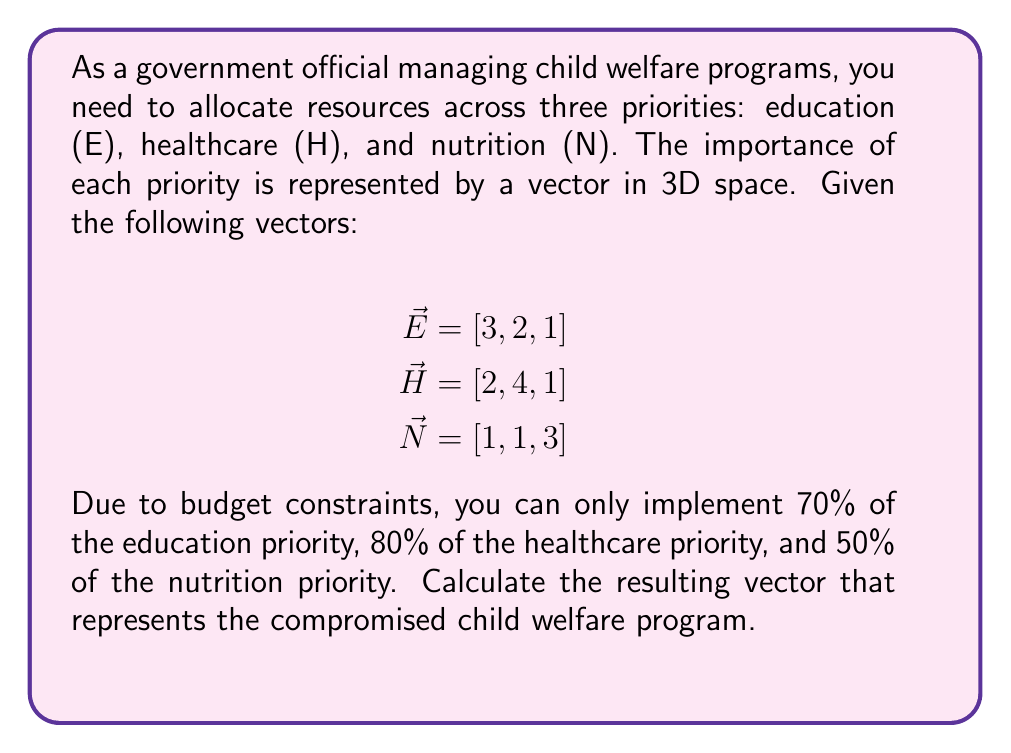Provide a solution to this math problem. To solve this problem, we need to use scalar multiplication and vector addition. Let's break it down step-by-step:

1) First, we need to apply the budget constraints to each priority vector using scalar multiplication:

   Education: $0.70 \cdot \vec{E} = 0.70 \cdot [3, 2, 1] = [2.1, 1.4, 0.7]$
   Healthcare: $0.80 \cdot \vec{H} = 0.80 \cdot [2, 4, 1] = [1.6, 3.2, 0.8]$
   Nutrition: $0.50 \cdot \vec{N} = 0.50 \cdot [1, 1, 3] = [0.5, 0.5, 1.5]$

2) Now, we need to add these scaled vectors to get the resulting compromised program vector:

   $\vec{R} = 0.70\vec{E} + 0.80\vec{H} + 0.50\vec{N}$

3) Let's add the vectors component-wise:

   $\vec{R} = [2.1, 1.4, 0.7] + [1.6, 3.2, 0.8] + [0.5, 0.5, 1.5]$

4) Summing up each component:

   $\vec{R} = [2.1 + 1.6 + 0.5, 1.4 + 3.2 + 0.5, 0.7 + 0.8 + 1.5]$

5) Calculating the final result:

   $\vec{R} = [4.2, 5.1, 3.0]$

This resulting vector represents the compromised child welfare program, taking into account the budget constraints applied to each priority.
Answer: $\vec{R} = [4.2, 5.1, 3.0]$ 